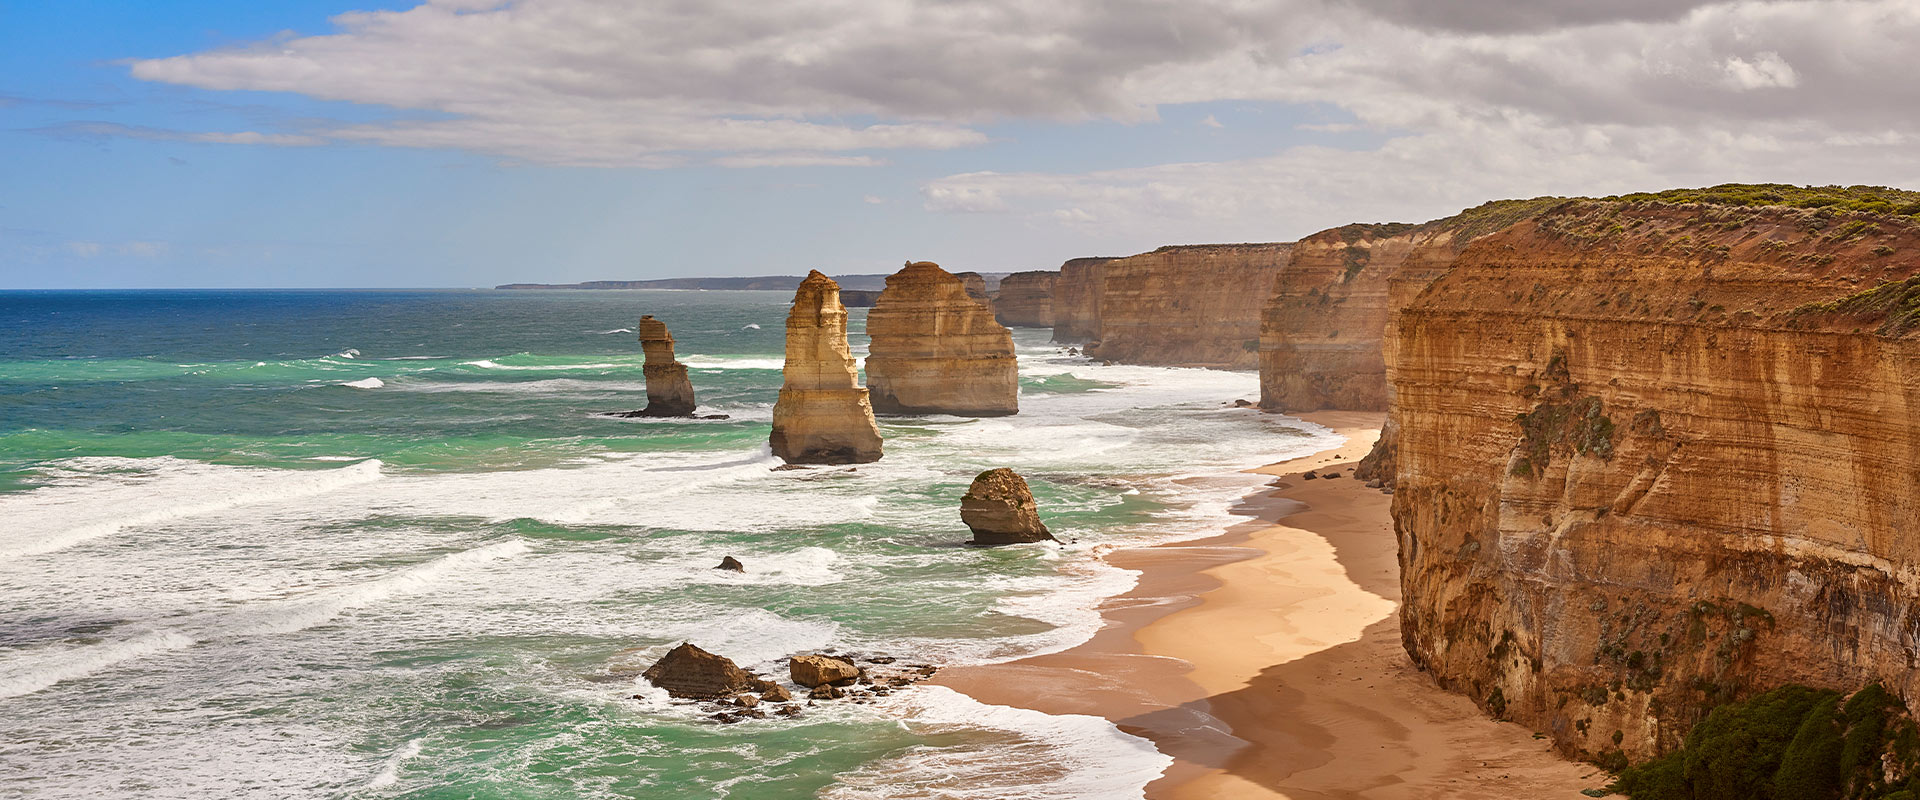What can you tell me about the geological formation of the Twelve Apostles? The Twelve Apostles are formed from limestone, which was originally deposited as sediment from a shallow sea roughly 10 to 20 million years ago. Over time, the ocean's erosive forces sculpted these rocks into caves, then into arches, and eventually, as the arches collapsed, into the isolated stacks we see today. This natural process is ongoing, so the landscape continues to dynamically change. 